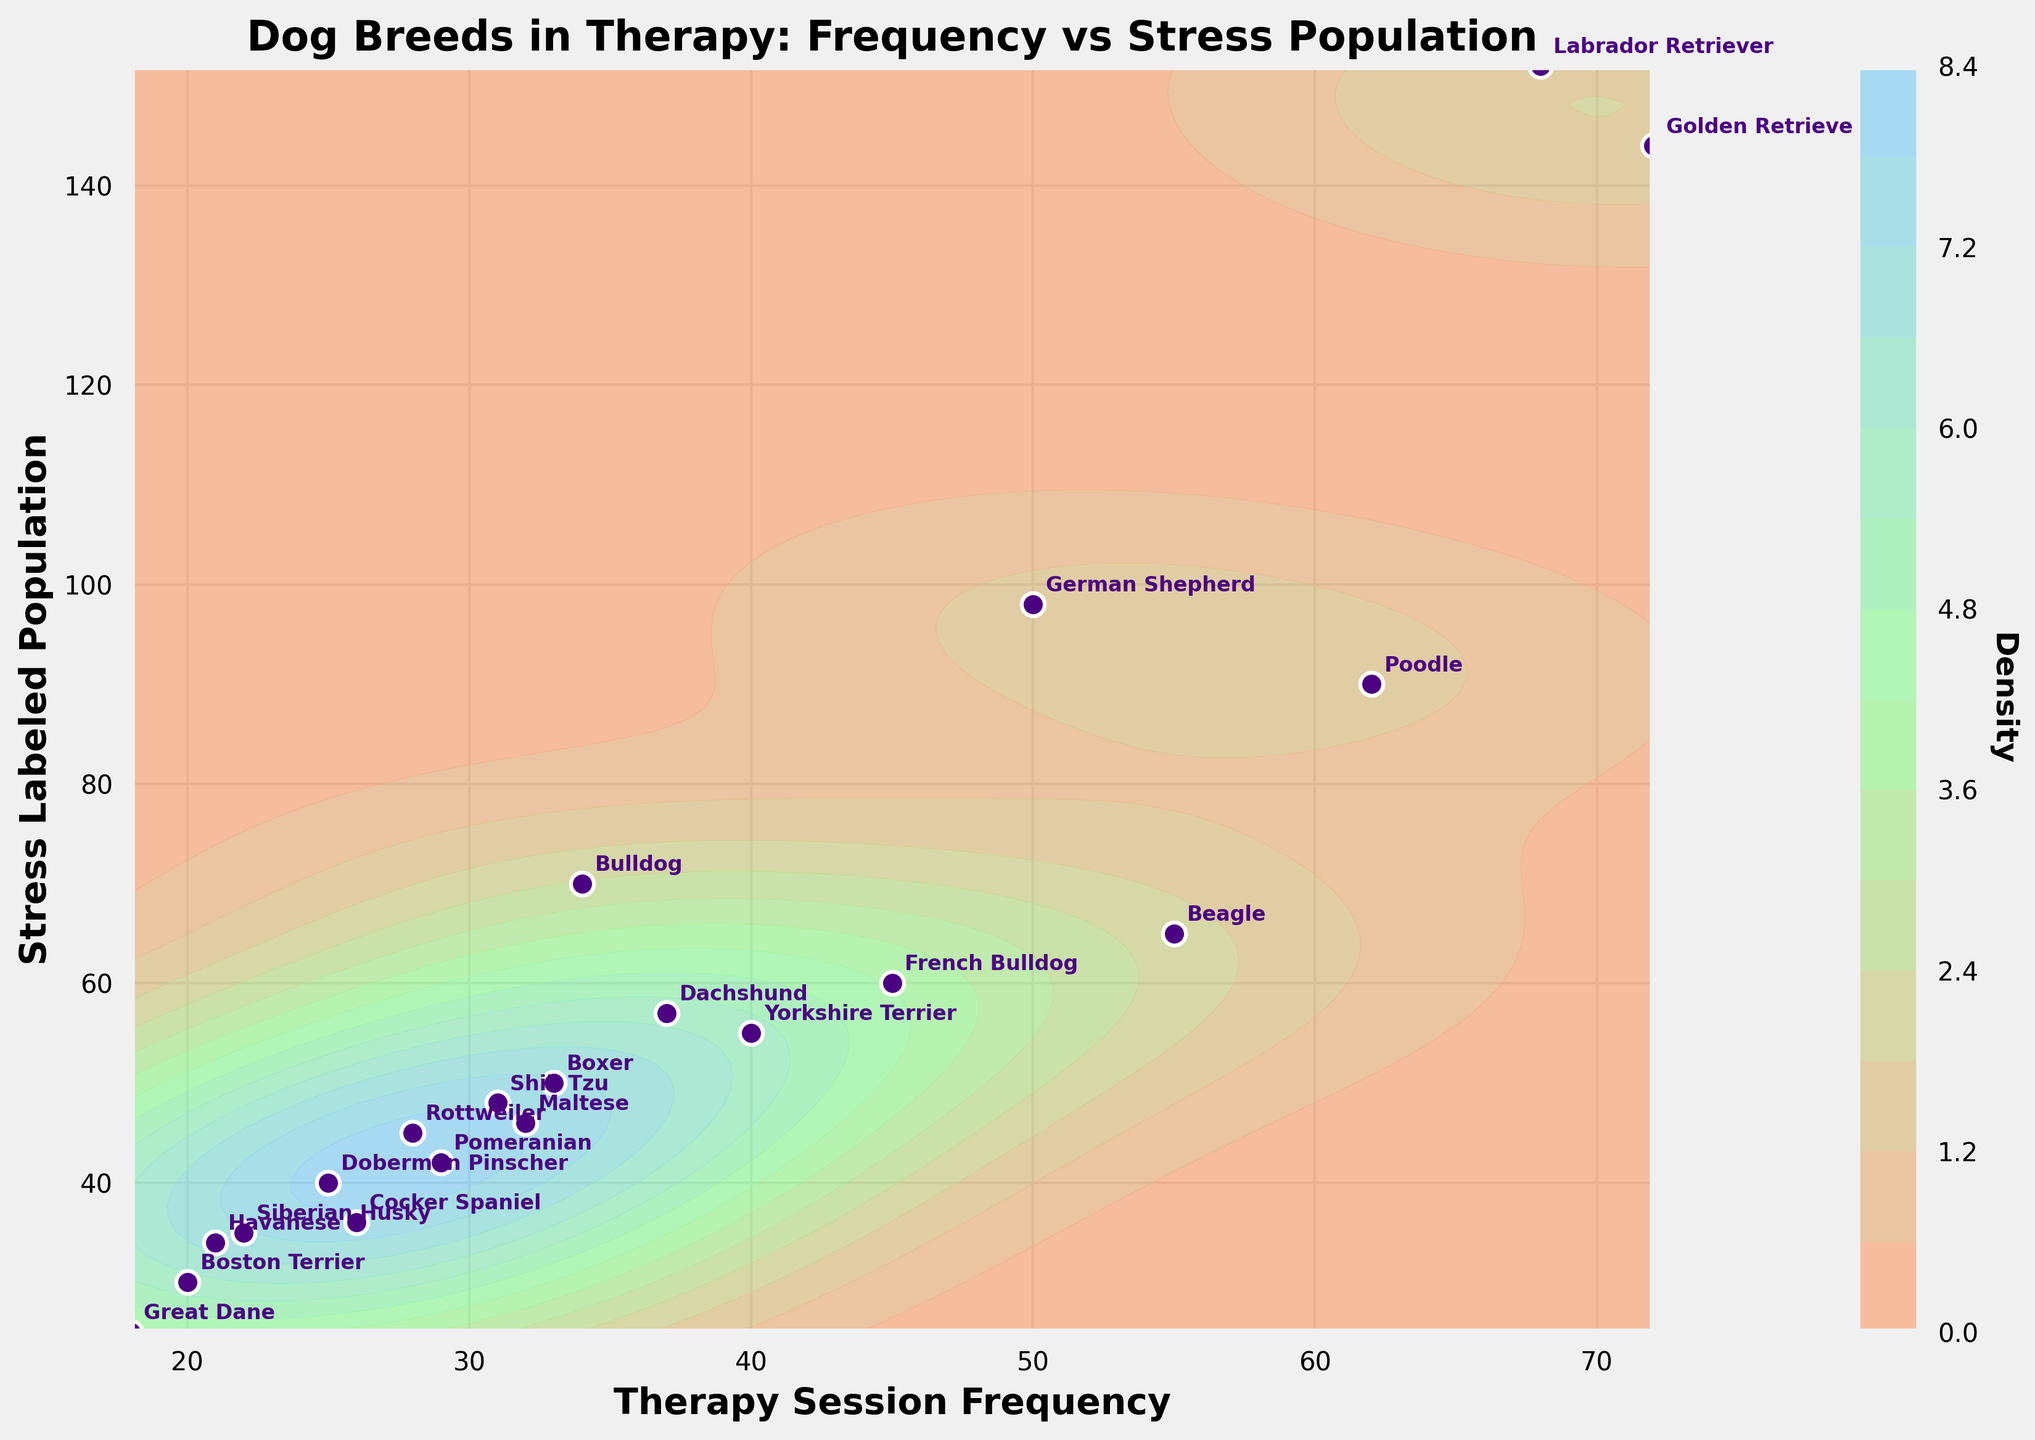What is the title of the plot? The title of the plot is located at the top center of the image and provides a summary of what the plot represents.
Answer: Dog Breeds in Therapy: Frequency vs Stress Population What are the labels on the x and y axes? The labels on the x-axis and y-axis are found at the bottom and left side of the plot, respectively, and indicate the variables being compared. The x-axis represents "Therapy Session Frequency" and the y-axis represents "Stress Labeled Population".
Answer: Therapy Session Frequency, Stress Labeled Population Which dog breed has the highest therapy session frequency? By looking at the points annotated with dog breed names on the plot, the dog breed with the highest x-coordinate is the one with the highest therapy session frequency.
Answer: Golden Retriever Which dog breed has the lowest stress labeled population? By locating the points on the plot with the smallest y-coordinate and reading the corresponding label, we find the dog breed with the lowest stress labeled population.
Answer: Great Dane What is the main color of the contour plot? The contour plot's color scheme is discernible by observing the varying shades and gradients used to represent density levels.
Answer: A gradient between light salmon, pale green, and sky blue How many dog breeds are plotted on the graph? Counting each annotated point on the graph gives the total number of dog breeds represented.
Answer: 20 How does the therapy session frequency of French Bulldog compare to Yorkshire Terrier? By identifying the positions of French Bulldog and Yorkshire Terrier on the x-axis, we compare their therapy session frequencies. The French Bulldog (45) has a lower value than the Yorkshire Terrier (40).
Answer: French Bulldog: 45, Yorkshire Terrier: 40 Among the breeds Labrador Retriever, Beagle, and Shih Tzu, which has the highest stress labeled population? By examining the y-coordinates of the points labeled Labrador Retriever, Beagle, and Shih Tzu, the breed with the highest stress labeled population is identified.
Answer: Labrador Retriever What's the average therapy session frequency for Golden Retriever, Poodle, and Beagle? By adding the therapy session frequencies of Golden Retriever (72), Poodle (62), and Beagle (55), then dividing by the number of breeds (3), we get the average. The sum is 72 + 62 + 55 = 189, so the average is 189/3 = 63.
Answer: 63 Is the density higher around data points with higher or lower stress labeled populations? Observing the shading of the contour plot around points with higher y-coordinates (stress labeled population) helps determine where the density is higher. Typically, density appears higher around the mid to lower stress labeled populations.
Answer: Lower stress labeled populations 